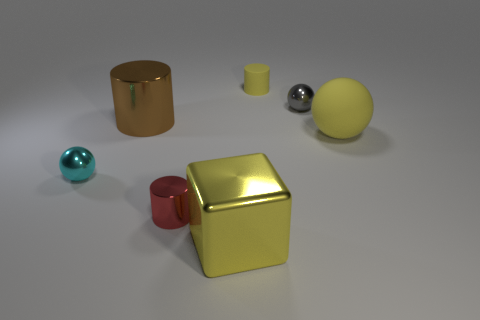Subtract 1 cylinders. How many cylinders are left? 2 Add 1 large yellow matte spheres. How many objects exist? 8 Subtract all cylinders. How many objects are left? 4 Add 6 gray spheres. How many gray spheres are left? 7 Add 5 tiny red metal cylinders. How many tiny red metal cylinders exist? 6 Subtract 0 blue balls. How many objects are left? 7 Subtract all gray metal cylinders. Subtract all small matte objects. How many objects are left? 6 